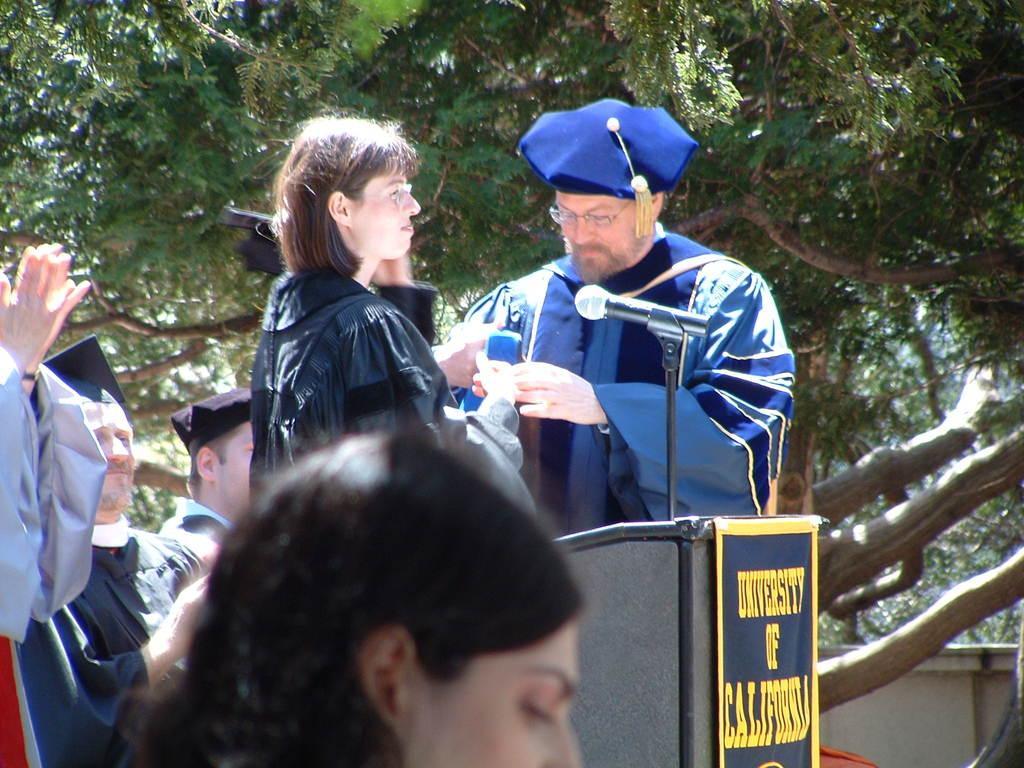Can you describe this image briefly? In this image, there are a few people. We can see the podium, a board with some text and a microphone. There are a few trees. We can also see the wall. 